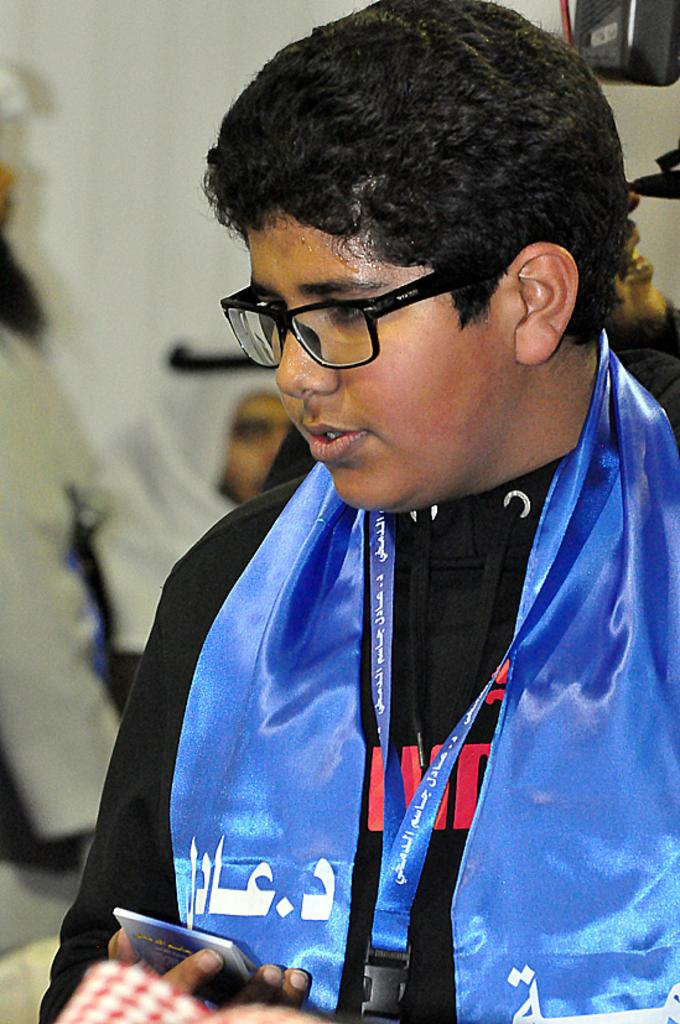What is the main subject of the image? The main subject of the image is a boy. What is the boy wearing in the image? The boy is wearing a black T-shirt in the image. What is the boy holding in the image? The boy is holding an object in the image. How does the boy use his muscles to swim in the ocean in the image? There is no ocean or swimming activity depicted in the image; the boy is simply holding an object. 